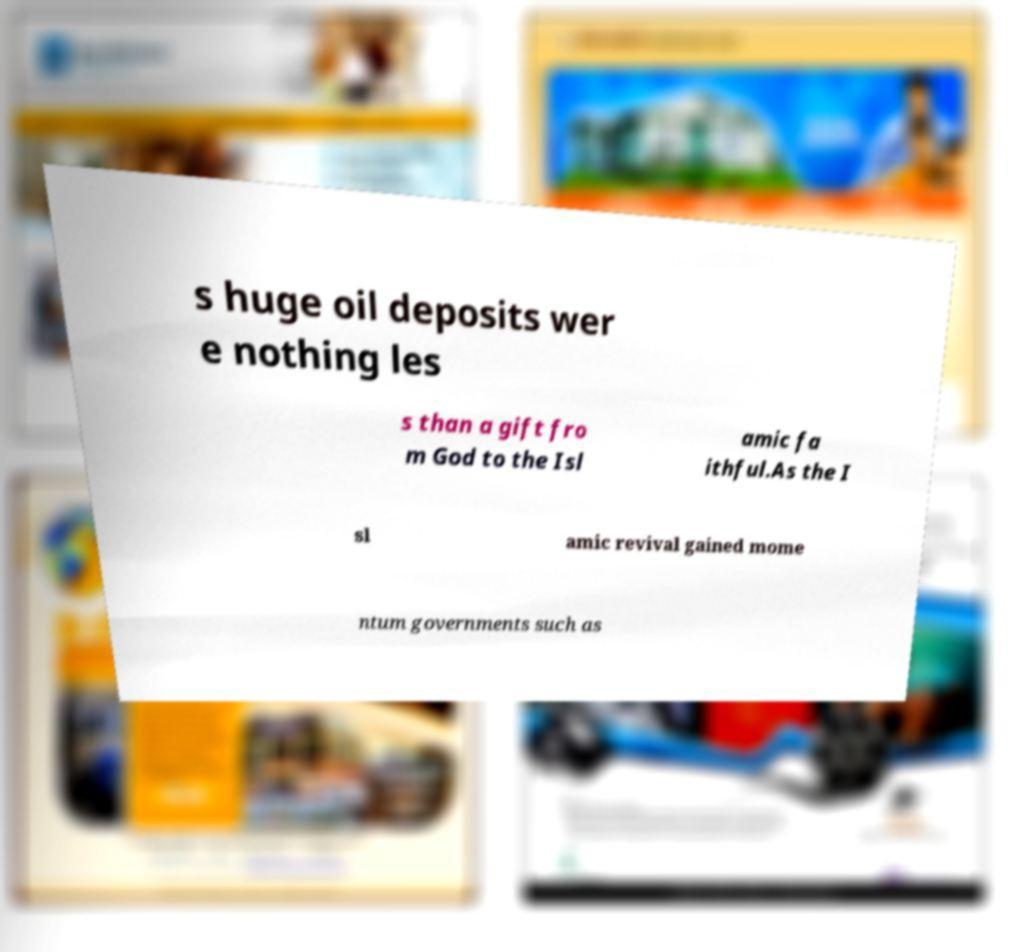Please identify and transcribe the text found in this image. s huge oil deposits wer e nothing les s than a gift fro m God to the Isl amic fa ithful.As the I sl amic revival gained mome ntum governments such as 